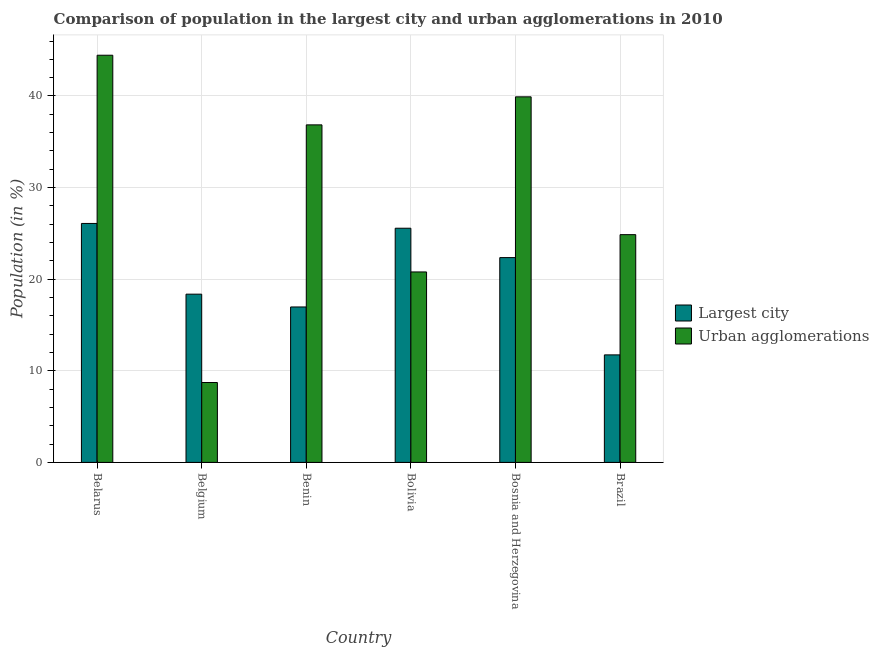How many groups of bars are there?
Provide a succinct answer. 6. Are the number of bars on each tick of the X-axis equal?
Provide a succinct answer. Yes. In how many cases, is the number of bars for a given country not equal to the number of legend labels?
Offer a very short reply. 0. What is the population in the largest city in Bolivia?
Your answer should be very brief. 25.56. Across all countries, what is the maximum population in the largest city?
Offer a terse response. 26.08. Across all countries, what is the minimum population in urban agglomerations?
Your answer should be compact. 8.72. In which country was the population in the largest city maximum?
Ensure brevity in your answer.  Belarus. What is the total population in urban agglomerations in the graph?
Your answer should be compact. 175.57. What is the difference between the population in the largest city in Bosnia and Herzegovina and that in Brazil?
Provide a succinct answer. 10.62. What is the difference between the population in urban agglomerations in Benin and the population in the largest city in Belgium?
Your answer should be very brief. 18.48. What is the average population in the largest city per country?
Offer a terse response. 20.18. What is the difference between the population in the largest city and population in urban agglomerations in Brazil?
Offer a very short reply. -13.12. In how many countries, is the population in urban agglomerations greater than 28 %?
Ensure brevity in your answer.  3. What is the ratio of the population in the largest city in Belarus to that in Brazil?
Provide a short and direct response. 2.22. Is the population in the largest city in Belarus less than that in Bosnia and Herzegovina?
Give a very brief answer. No. Is the difference between the population in urban agglomerations in Belgium and Bolivia greater than the difference between the population in the largest city in Belgium and Bolivia?
Make the answer very short. No. What is the difference between the highest and the second highest population in urban agglomerations?
Your response must be concise. 4.54. What is the difference between the highest and the lowest population in the largest city?
Provide a succinct answer. 14.35. In how many countries, is the population in the largest city greater than the average population in the largest city taken over all countries?
Provide a succinct answer. 3. What does the 1st bar from the left in Bolivia represents?
Your answer should be compact. Largest city. What does the 1st bar from the right in Belgium represents?
Your answer should be compact. Urban agglomerations. Are all the bars in the graph horizontal?
Your answer should be very brief. No. Does the graph contain grids?
Keep it short and to the point. Yes. How many legend labels are there?
Offer a very short reply. 2. How are the legend labels stacked?
Provide a succinct answer. Vertical. What is the title of the graph?
Offer a terse response. Comparison of population in the largest city and urban agglomerations in 2010. Does "Attending school" appear as one of the legend labels in the graph?
Offer a terse response. No. What is the label or title of the X-axis?
Offer a very short reply. Country. What is the Population (in %) of Largest city in Belarus?
Offer a very short reply. 26.08. What is the Population (in %) in Urban agglomerations in Belarus?
Keep it short and to the point. 44.45. What is the Population (in %) in Largest city in Belgium?
Your answer should be compact. 18.36. What is the Population (in %) in Urban agglomerations in Belgium?
Ensure brevity in your answer.  8.72. What is the Population (in %) in Largest city in Benin?
Your response must be concise. 16.97. What is the Population (in %) of Urban agglomerations in Benin?
Offer a terse response. 36.85. What is the Population (in %) in Largest city in Bolivia?
Provide a short and direct response. 25.56. What is the Population (in %) of Urban agglomerations in Bolivia?
Provide a short and direct response. 20.79. What is the Population (in %) of Largest city in Bosnia and Herzegovina?
Provide a succinct answer. 22.36. What is the Population (in %) in Urban agglomerations in Bosnia and Herzegovina?
Give a very brief answer. 39.91. What is the Population (in %) in Largest city in Brazil?
Your answer should be very brief. 11.74. What is the Population (in %) of Urban agglomerations in Brazil?
Offer a terse response. 24.86. Across all countries, what is the maximum Population (in %) of Largest city?
Provide a short and direct response. 26.08. Across all countries, what is the maximum Population (in %) of Urban agglomerations?
Your answer should be very brief. 44.45. Across all countries, what is the minimum Population (in %) in Largest city?
Keep it short and to the point. 11.74. Across all countries, what is the minimum Population (in %) in Urban agglomerations?
Make the answer very short. 8.72. What is the total Population (in %) in Largest city in the graph?
Provide a succinct answer. 121.07. What is the total Population (in %) in Urban agglomerations in the graph?
Give a very brief answer. 175.57. What is the difference between the Population (in %) of Largest city in Belarus and that in Belgium?
Keep it short and to the point. 7.72. What is the difference between the Population (in %) of Urban agglomerations in Belarus and that in Belgium?
Give a very brief answer. 35.73. What is the difference between the Population (in %) of Largest city in Belarus and that in Benin?
Ensure brevity in your answer.  9.12. What is the difference between the Population (in %) in Urban agglomerations in Belarus and that in Benin?
Offer a terse response. 7.6. What is the difference between the Population (in %) of Largest city in Belarus and that in Bolivia?
Ensure brevity in your answer.  0.52. What is the difference between the Population (in %) in Urban agglomerations in Belarus and that in Bolivia?
Your answer should be compact. 23.66. What is the difference between the Population (in %) of Largest city in Belarus and that in Bosnia and Herzegovina?
Offer a very short reply. 3.73. What is the difference between the Population (in %) of Urban agglomerations in Belarus and that in Bosnia and Herzegovina?
Give a very brief answer. 4.54. What is the difference between the Population (in %) of Largest city in Belarus and that in Brazil?
Ensure brevity in your answer.  14.35. What is the difference between the Population (in %) in Urban agglomerations in Belarus and that in Brazil?
Provide a succinct answer. 19.59. What is the difference between the Population (in %) in Largest city in Belgium and that in Benin?
Provide a short and direct response. 1.4. What is the difference between the Population (in %) of Urban agglomerations in Belgium and that in Benin?
Ensure brevity in your answer.  -28.12. What is the difference between the Population (in %) of Largest city in Belgium and that in Bolivia?
Provide a succinct answer. -7.2. What is the difference between the Population (in %) in Urban agglomerations in Belgium and that in Bolivia?
Provide a succinct answer. -12.07. What is the difference between the Population (in %) in Largest city in Belgium and that in Bosnia and Herzegovina?
Keep it short and to the point. -3.99. What is the difference between the Population (in %) in Urban agglomerations in Belgium and that in Bosnia and Herzegovina?
Your answer should be very brief. -31.18. What is the difference between the Population (in %) in Largest city in Belgium and that in Brazil?
Give a very brief answer. 6.63. What is the difference between the Population (in %) in Urban agglomerations in Belgium and that in Brazil?
Provide a short and direct response. -16.14. What is the difference between the Population (in %) in Largest city in Benin and that in Bolivia?
Offer a very short reply. -8.6. What is the difference between the Population (in %) of Urban agglomerations in Benin and that in Bolivia?
Offer a very short reply. 16.06. What is the difference between the Population (in %) of Largest city in Benin and that in Bosnia and Herzegovina?
Make the answer very short. -5.39. What is the difference between the Population (in %) in Urban agglomerations in Benin and that in Bosnia and Herzegovina?
Keep it short and to the point. -3.06. What is the difference between the Population (in %) in Largest city in Benin and that in Brazil?
Your answer should be compact. 5.23. What is the difference between the Population (in %) in Urban agglomerations in Benin and that in Brazil?
Your answer should be compact. 11.98. What is the difference between the Population (in %) in Largest city in Bolivia and that in Bosnia and Herzegovina?
Offer a terse response. 3.21. What is the difference between the Population (in %) in Urban agglomerations in Bolivia and that in Bosnia and Herzegovina?
Your answer should be very brief. -19.11. What is the difference between the Population (in %) of Largest city in Bolivia and that in Brazil?
Keep it short and to the point. 13.83. What is the difference between the Population (in %) of Urban agglomerations in Bolivia and that in Brazil?
Keep it short and to the point. -4.07. What is the difference between the Population (in %) of Largest city in Bosnia and Herzegovina and that in Brazil?
Offer a terse response. 10.62. What is the difference between the Population (in %) of Urban agglomerations in Bosnia and Herzegovina and that in Brazil?
Give a very brief answer. 15.04. What is the difference between the Population (in %) in Largest city in Belarus and the Population (in %) in Urban agglomerations in Belgium?
Your answer should be very brief. 17.36. What is the difference between the Population (in %) of Largest city in Belarus and the Population (in %) of Urban agglomerations in Benin?
Offer a very short reply. -10.76. What is the difference between the Population (in %) in Largest city in Belarus and the Population (in %) in Urban agglomerations in Bolivia?
Provide a short and direct response. 5.29. What is the difference between the Population (in %) of Largest city in Belarus and the Population (in %) of Urban agglomerations in Bosnia and Herzegovina?
Your response must be concise. -13.82. What is the difference between the Population (in %) in Largest city in Belarus and the Population (in %) in Urban agglomerations in Brazil?
Keep it short and to the point. 1.22. What is the difference between the Population (in %) in Largest city in Belgium and the Population (in %) in Urban agglomerations in Benin?
Your answer should be compact. -18.48. What is the difference between the Population (in %) in Largest city in Belgium and the Population (in %) in Urban agglomerations in Bolivia?
Provide a short and direct response. -2.43. What is the difference between the Population (in %) of Largest city in Belgium and the Population (in %) of Urban agglomerations in Bosnia and Herzegovina?
Provide a short and direct response. -21.54. What is the difference between the Population (in %) of Largest city in Belgium and the Population (in %) of Urban agglomerations in Brazil?
Your answer should be compact. -6.5. What is the difference between the Population (in %) of Largest city in Benin and the Population (in %) of Urban agglomerations in Bolivia?
Make the answer very short. -3.82. What is the difference between the Population (in %) in Largest city in Benin and the Population (in %) in Urban agglomerations in Bosnia and Herzegovina?
Your answer should be compact. -22.94. What is the difference between the Population (in %) of Largest city in Benin and the Population (in %) of Urban agglomerations in Brazil?
Make the answer very short. -7.89. What is the difference between the Population (in %) of Largest city in Bolivia and the Population (in %) of Urban agglomerations in Bosnia and Herzegovina?
Make the answer very short. -14.34. What is the difference between the Population (in %) of Largest city in Bolivia and the Population (in %) of Urban agglomerations in Brazil?
Ensure brevity in your answer.  0.7. What is the difference between the Population (in %) of Largest city in Bosnia and Herzegovina and the Population (in %) of Urban agglomerations in Brazil?
Give a very brief answer. -2.51. What is the average Population (in %) of Largest city per country?
Provide a short and direct response. 20.18. What is the average Population (in %) of Urban agglomerations per country?
Your answer should be compact. 29.26. What is the difference between the Population (in %) in Largest city and Population (in %) in Urban agglomerations in Belarus?
Ensure brevity in your answer.  -18.36. What is the difference between the Population (in %) of Largest city and Population (in %) of Urban agglomerations in Belgium?
Provide a short and direct response. 9.64. What is the difference between the Population (in %) in Largest city and Population (in %) in Urban agglomerations in Benin?
Make the answer very short. -19.88. What is the difference between the Population (in %) of Largest city and Population (in %) of Urban agglomerations in Bolivia?
Provide a succinct answer. 4.77. What is the difference between the Population (in %) in Largest city and Population (in %) in Urban agglomerations in Bosnia and Herzegovina?
Offer a very short reply. -17.55. What is the difference between the Population (in %) in Largest city and Population (in %) in Urban agglomerations in Brazil?
Offer a very short reply. -13.12. What is the ratio of the Population (in %) of Largest city in Belarus to that in Belgium?
Your answer should be very brief. 1.42. What is the ratio of the Population (in %) of Urban agglomerations in Belarus to that in Belgium?
Keep it short and to the point. 5.1. What is the ratio of the Population (in %) of Largest city in Belarus to that in Benin?
Ensure brevity in your answer.  1.54. What is the ratio of the Population (in %) of Urban agglomerations in Belarus to that in Benin?
Offer a very short reply. 1.21. What is the ratio of the Population (in %) of Largest city in Belarus to that in Bolivia?
Your answer should be compact. 1.02. What is the ratio of the Population (in %) in Urban agglomerations in Belarus to that in Bolivia?
Keep it short and to the point. 2.14. What is the ratio of the Population (in %) of Largest city in Belarus to that in Bosnia and Herzegovina?
Make the answer very short. 1.17. What is the ratio of the Population (in %) in Urban agglomerations in Belarus to that in Bosnia and Herzegovina?
Your answer should be very brief. 1.11. What is the ratio of the Population (in %) of Largest city in Belarus to that in Brazil?
Provide a short and direct response. 2.22. What is the ratio of the Population (in %) of Urban agglomerations in Belarus to that in Brazil?
Give a very brief answer. 1.79. What is the ratio of the Population (in %) of Largest city in Belgium to that in Benin?
Your answer should be compact. 1.08. What is the ratio of the Population (in %) in Urban agglomerations in Belgium to that in Benin?
Provide a succinct answer. 0.24. What is the ratio of the Population (in %) in Largest city in Belgium to that in Bolivia?
Offer a terse response. 0.72. What is the ratio of the Population (in %) of Urban agglomerations in Belgium to that in Bolivia?
Give a very brief answer. 0.42. What is the ratio of the Population (in %) in Largest city in Belgium to that in Bosnia and Herzegovina?
Your answer should be very brief. 0.82. What is the ratio of the Population (in %) in Urban agglomerations in Belgium to that in Bosnia and Herzegovina?
Your answer should be compact. 0.22. What is the ratio of the Population (in %) in Largest city in Belgium to that in Brazil?
Make the answer very short. 1.56. What is the ratio of the Population (in %) in Urban agglomerations in Belgium to that in Brazil?
Keep it short and to the point. 0.35. What is the ratio of the Population (in %) in Largest city in Benin to that in Bolivia?
Keep it short and to the point. 0.66. What is the ratio of the Population (in %) of Urban agglomerations in Benin to that in Bolivia?
Give a very brief answer. 1.77. What is the ratio of the Population (in %) of Largest city in Benin to that in Bosnia and Herzegovina?
Keep it short and to the point. 0.76. What is the ratio of the Population (in %) in Urban agglomerations in Benin to that in Bosnia and Herzegovina?
Provide a short and direct response. 0.92. What is the ratio of the Population (in %) in Largest city in Benin to that in Brazil?
Keep it short and to the point. 1.45. What is the ratio of the Population (in %) in Urban agglomerations in Benin to that in Brazil?
Offer a very short reply. 1.48. What is the ratio of the Population (in %) of Largest city in Bolivia to that in Bosnia and Herzegovina?
Provide a short and direct response. 1.14. What is the ratio of the Population (in %) of Urban agglomerations in Bolivia to that in Bosnia and Herzegovina?
Make the answer very short. 0.52. What is the ratio of the Population (in %) in Largest city in Bolivia to that in Brazil?
Your answer should be compact. 2.18. What is the ratio of the Population (in %) in Urban agglomerations in Bolivia to that in Brazil?
Offer a very short reply. 0.84. What is the ratio of the Population (in %) in Largest city in Bosnia and Herzegovina to that in Brazil?
Your answer should be very brief. 1.9. What is the ratio of the Population (in %) of Urban agglomerations in Bosnia and Herzegovina to that in Brazil?
Give a very brief answer. 1.61. What is the difference between the highest and the second highest Population (in %) of Largest city?
Your answer should be very brief. 0.52. What is the difference between the highest and the second highest Population (in %) in Urban agglomerations?
Make the answer very short. 4.54. What is the difference between the highest and the lowest Population (in %) in Largest city?
Your answer should be very brief. 14.35. What is the difference between the highest and the lowest Population (in %) of Urban agglomerations?
Your answer should be compact. 35.73. 